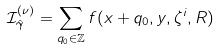<formula> <loc_0><loc_0><loc_500><loc_500>\mathcal { I } _ { \hat { \gamma } } ^ { ( \nu ) } = \sum _ { q _ { 0 } \in \mathbb { Z } } f ( x + q _ { 0 } , y , \zeta ^ { i } , R )</formula> 